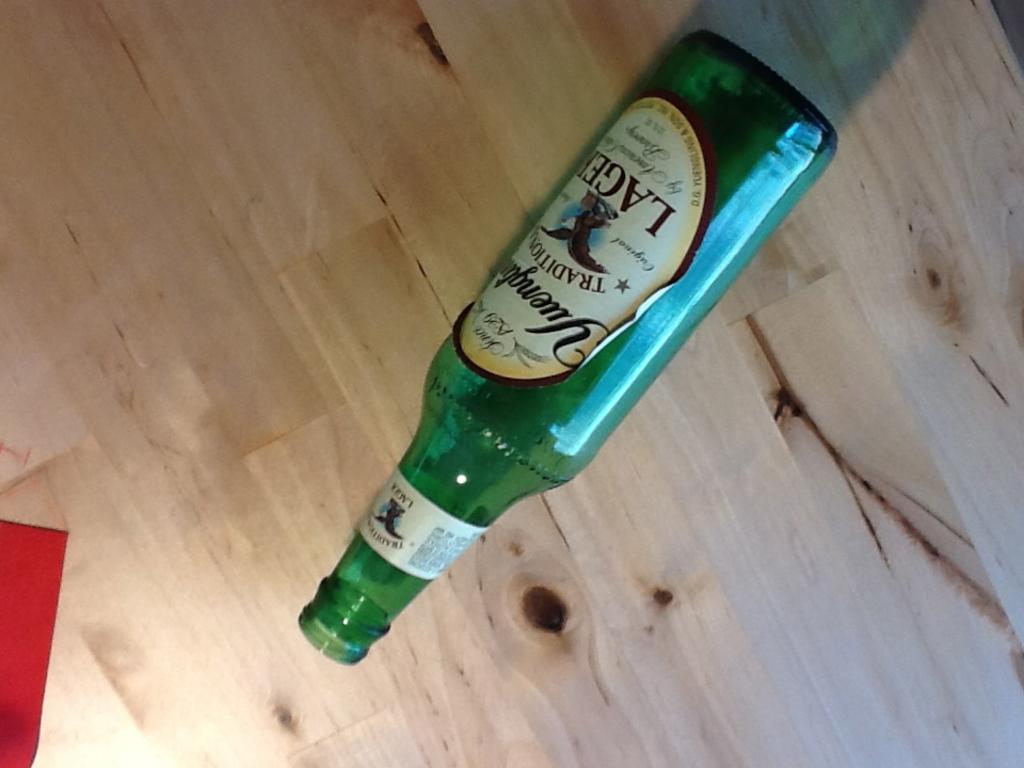What type of beer is this?
Your answer should be compact. Lager. 